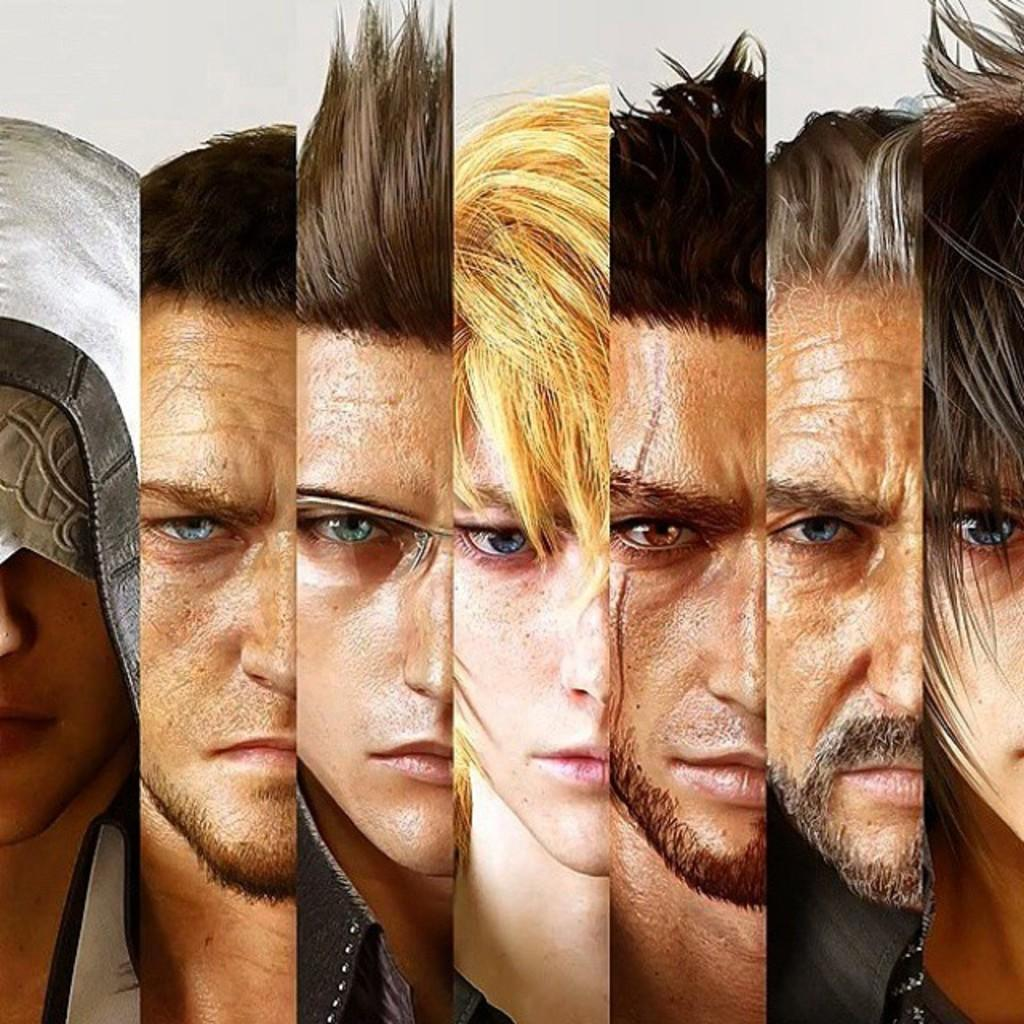What is the main subject of the image? The main subject of the image is a collage of human faces. Can you describe the composition of the image? The image is composed of various human faces arranged together in a collage. What type of waste is visible in the image? There is no waste visible in the image; it is a collage of human faces. What color is the gold in the image? There is no gold present in the image; it is a collage of human faces. 